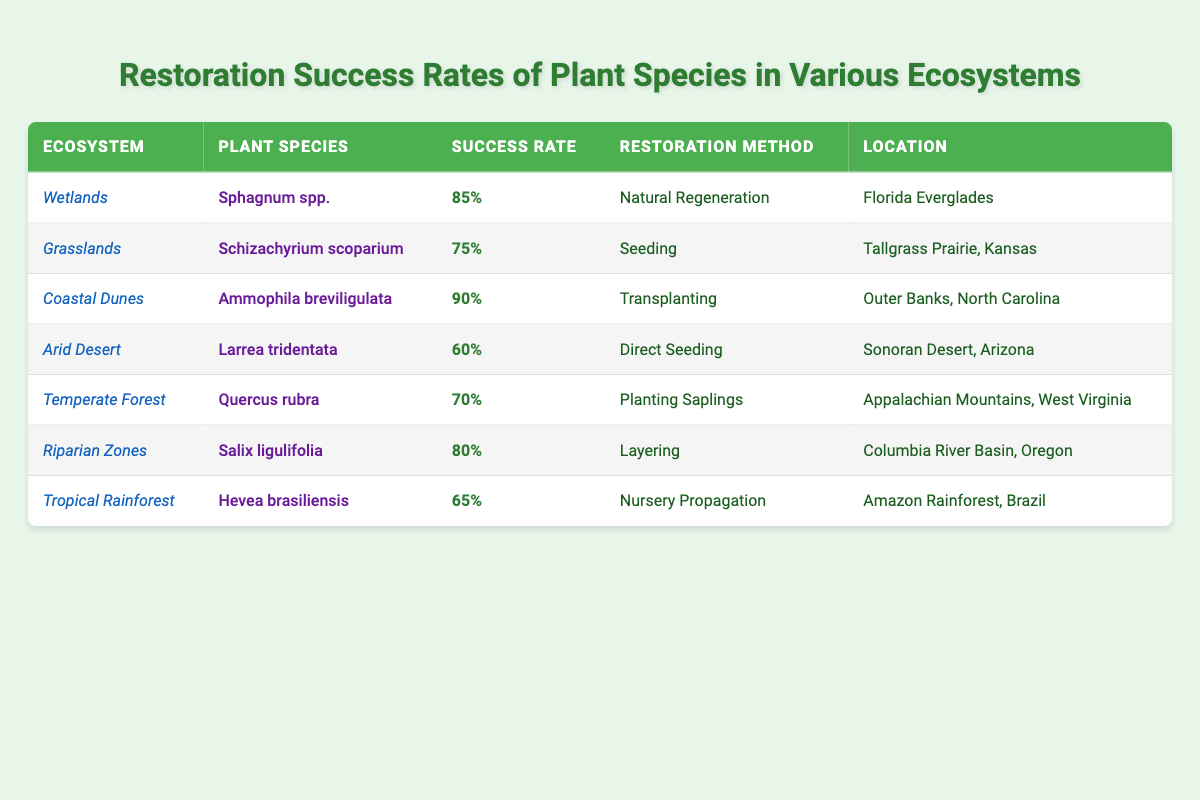What is the success rate of Sphagnum spp. in Wetlands? The table lists the success rate for Sphagnum spp. under the Wetlands ecosystem, which is noted as 85%.
Answer: 85% Which restoration method is used for Quercus rubra in Temperate Forest? The table indicates that Quercus rubra in the Temperate Forest ecosystem is restored using the method of Planting Saplings.
Answer: Planting Saplings What is the average success rate of all plant species listed? To find the average, we first convert each percentage to a numerical value: 85, 75, 90, 60, 70, 80, 65. The total is 85 + 75 + 90 + 60 + 70 + 80 + 65 = 525. There are 7 species, so the average success rate is 525/7 = 75%.
Answer: 75% Is the success rate of Ammophila breviligulata higher than that of Larrea tridentata? Ammophila breviligulata has a success rate of 90%, while Larrea tridentata has a success rate of 60%. Since 90% is greater than 60%, the statement is true.
Answer: Yes Which plant species has the highest success rate and what is that rate? By examining the success rates in the table, Ammophila breviligulata has the highest success rate at 90%. This is the maximum value across all entries.
Answer: Ammophila breviligulata, 90% What ecosystem has the lowest average success rate among the listed species? To find the lowest average, we compare the success rates of all ecosystems: Wetlands 85%, Grasslands 75%, Coastal Dunes 90%, Arid Desert 60%, Temperate Forest 70%, Riparian Zones 80%, and Tropical Rainforest 65%. The Arid Desert has the lowest success rate of 60%.
Answer: Arid Desert How many species have a success rate above 70%? Looking at the success rate values: Sphagnum spp. (85%), Ammophila breviligulata (90%), Riparian Zones (80%), and Grasslands (75%). This totals four species above 70%.
Answer: Four species Does Hevea brasiliensis have a success rate of 70% or above? Hevea brasiliensis has a success rate of 65%, which is below 70%. Therefore, the statement is false.
Answer: No Which restoration methods are used for ecosystems with a success rate over 80%? The ecosystems with a success rate over 80% are Wetlands (Natural Regeneration), Coastal Dunes (Transplanting), and Riparian Zones (Layering). Thus, the methods are Natural Regeneration, Transplanting, and Layering.
Answer: Natural Regeneration, Transplanting, Layering 